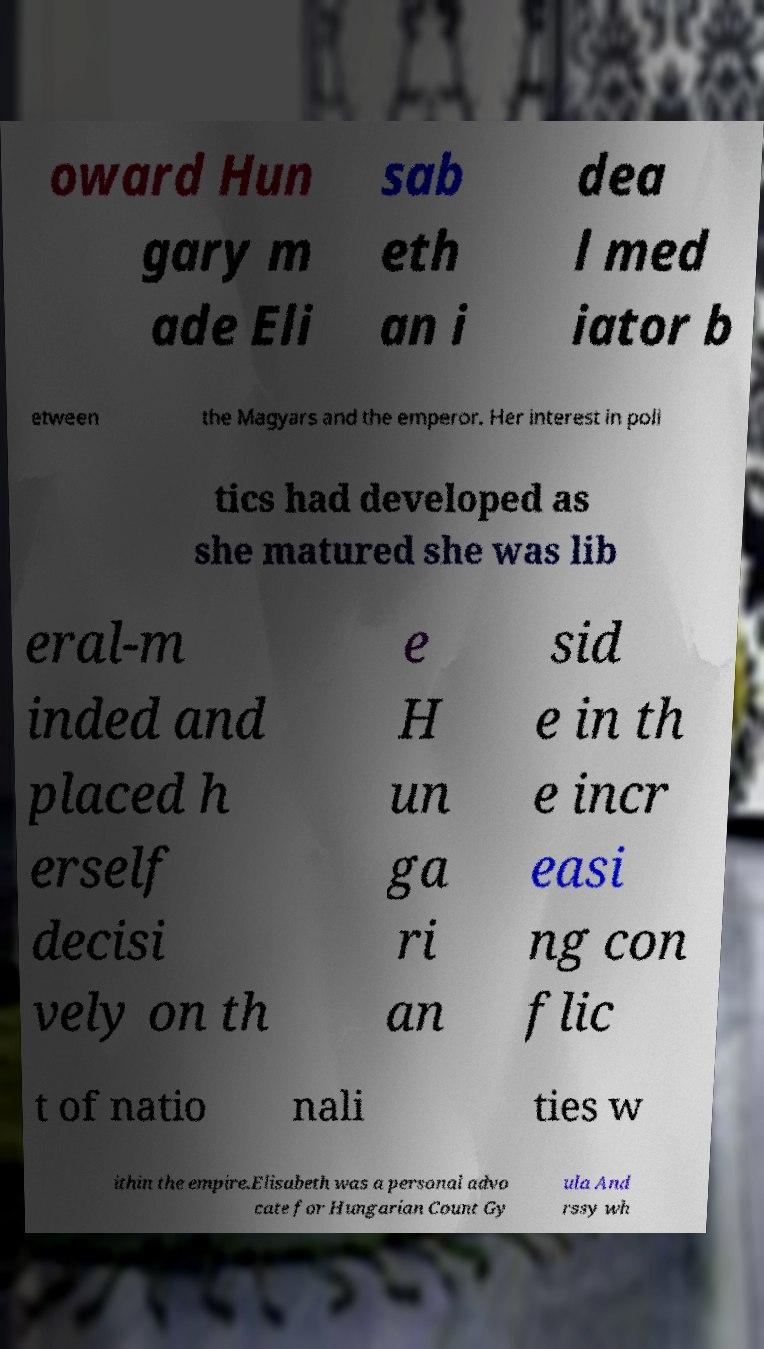Could you assist in decoding the text presented in this image and type it out clearly? oward Hun gary m ade Eli sab eth an i dea l med iator b etween the Magyars and the emperor. Her interest in poli tics had developed as she matured she was lib eral-m inded and placed h erself decisi vely on th e H un ga ri an sid e in th e incr easi ng con flic t of natio nali ties w ithin the empire.Elisabeth was a personal advo cate for Hungarian Count Gy ula And rssy wh 